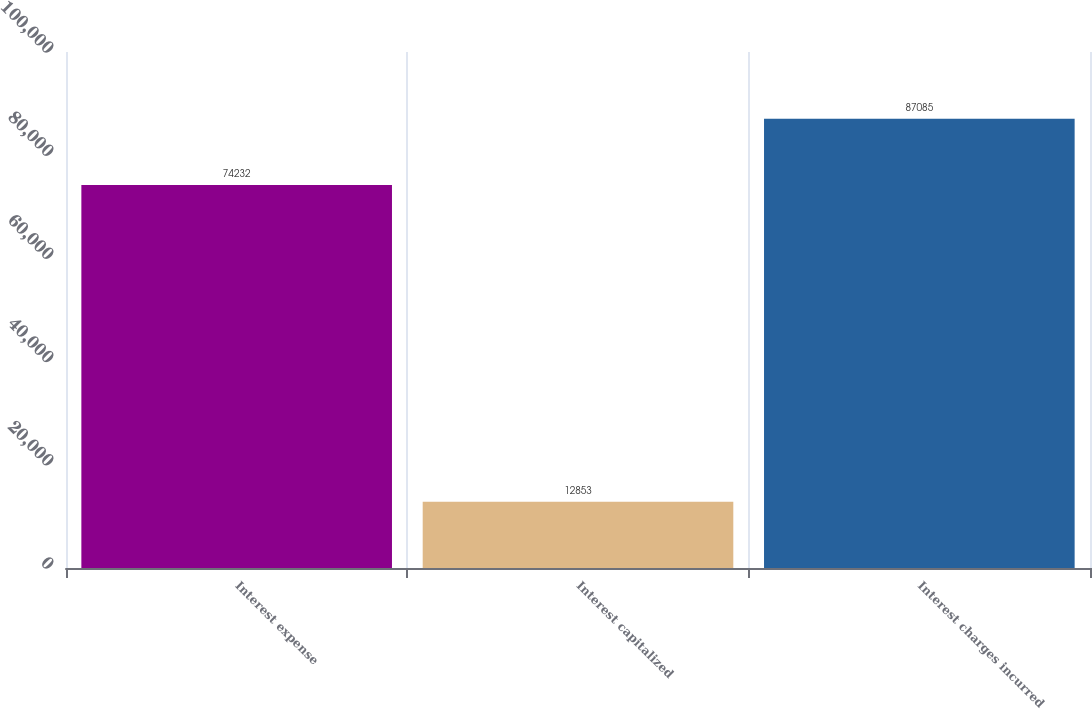Convert chart. <chart><loc_0><loc_0><loc_500><loc_500><bar_chart><fcel>Interest expense<fcel>Interest capitalized<fcel>Interest charges incurred<nl><fcel>74232<fcel>12853<fcel>87085<nl></chart> 